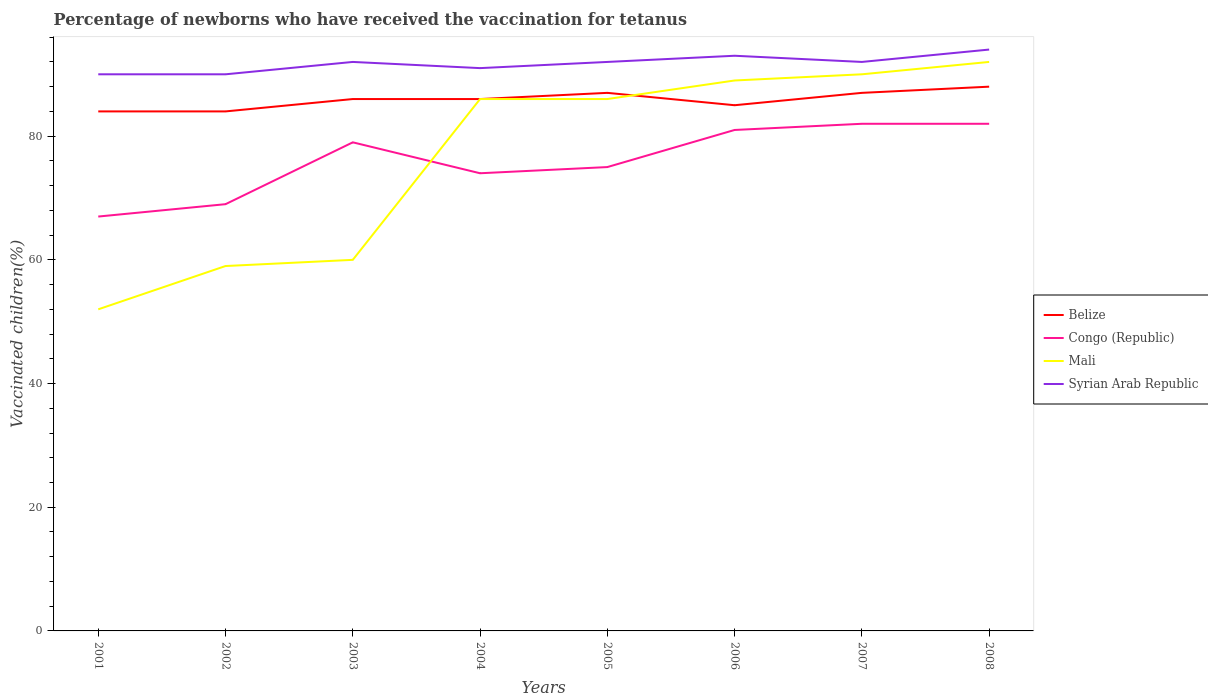How many different coloured lines are there?
Ensure brevity in your answer.  4. Is the number of lines equal to the number of legend labels?
Offer a terse response. Yes. Across all years, what is the maximum percentage of vaccinated children in Mali?
Offer a very short reply. 52. What is the total percentage of vaccinated children in Mali in the graph?
Give a very brief answer. -34. What is the difference between the highest and the second highest percentage of vaccinated children in Syrian Arab Republic?
Your response must be concise. 4. Is the percentage of vaccinated children in Congo (Republic) strictly greater than the percentage of vaccinated children in Belize over the years?
Provide a short and direct response. Yes. How many lines are there?
Keep it short and to the point. 4. Are the values on the major ticks of Y-axis written in scientific E-notation?
Your answer should be compact. No. Does the graph contain grids?
Ensure brevity in your answer.  No. Where does the legend appear in the graph?
Ensure brevity in your answer.  Center right. What is the title of the graph?
Provide a succinct answer. Percentage of newborns who have received the vaccination for tetanus. Does "Central African Republic" appear as one of the legend labels in the graph?
Provide a short and direct response. No. What is the label or title of the X-axis?
Offer a terse response. Years. What is the label or title of the Y-axis?
Offer a very short reply. Vaccinated children(%). What is the Vaccinated children(%) of Syrian Arab Republic in 2001?
Your response must be concise. 90. What is the Vaccinated children(%) in Belize in 2002?
Offer a terse response. 84. What is the Vaccinated children(%) in Congo (Republic) in 2002?
Keep it short and to the point. 69. What is the Vaccinated children(%) in Belize in 2003?
Your answer should be very brief. 86. What is the Vaccinated children(%) in Congo (Republic) in 2003?
Your response must be concise. 79. What is the Vaccinated children(%) in Syrian Arab Republic in 2003?
Give a very brief answer. 92. What is the Vaccinated children(%) of Mali in 2004?
Provide a short and direct response. 86. What is the Vaccinated children(%) in Syrian Arab Republic in 2004?
Provide a short and direct response. 91. What is the Vaccinated children(%) of Congo (Republic) in 2005?
Give a very brief answer. 75. What is the Vaccinated children(%) in Mali in 2005?
Offer a terse response. 86. What is the Vaccinated children(%) of Syrian Arab Republic in 2005?
Offer a very short reply. 92. What is the Vaccinated children(%) in Belize in 2006?
Make the answer very short. 85. What is the Vaccinated children(%) of Mali in 2006?
Offer a terse response. 89. What is the Vaccinated children(%) of Syrian Arab Republic in 2006?
Make the answer very short. 93. What is the Vaccinated children(%) of Belize in 2007?
Your answer should be compact. 87. What is the Vaccinated children(%) in Congo (Republic) in 2007?
Ensure brevity in your answer.  82. What is the Vaccinated children(%) in Syrian Arab Republic in 2007?
Provide a short and direct response. 92. What is the Vaccinated children(%) of Belize in 2008?
Provide a succinct answer. 88. What is the Vaccinated children(%) of Mali in 2008?
Your answer should be very brief. 92. What is the Vaccinated children(%) of Syrian Arab Republic in 2008?
Ensure brevity in your answer.  94. Across all years, what is the maximum Vaccinated children(%) in Belize?
Your response must be concise. 88. Across all years, what is the maximum Vaccinated children(%) of Mali?
Provide a succinct answer. 92. Across all years, what is the maximum Vaccinated children(%) of Syrian Arab Republic?
Ensure brevity in your answer.  94. Across all years, what is the minimum Vaccinated children(%) in Congo (Republic)?
Keep it short and to the point. 67. Across all years, what is the minimum Vaccinated children(%) in Mali?
Keep it short and to the point. 52. Across all years, what is the minimum Vaccinated children(%) of Syrian Arab Republic?
Provide a succinct answer. 90. What is the total Vaccinated children(%) of Belize in the graph?
Provide a short and direct response. 687. What is the total Vaccinated children(%) of Congo (Republic) in the graph?
Ensure brevity in your answer.  609. What is the total Vaccinated children(%) of Mali in the graph?
Make the answer very short. 614. What is the total Vaccinated children(%) of Syrian Arab Republic in the graph?
Give a very brief answer. 734. What is the difference between the Vaccinated children(%) of Congo (Republic) in 2001 and that in 2002?
Keep it short and to the point. -2. What is the difference between the Vaccinated children(%) in Mali in 2001 and that in 2002?
Make the answer very short. -7. What is the difference between the Vaccinated children(%) of Belize in 2001 and that in 2003?
Your answer should be very brief. -2. What is the difference between the Vaccinated children(%) of Congo (Republic) in 2001 and that in 2003?
Offer a terse response. -12. What is the difference between the Vaccinated children(%) of Mali in 2001 and that in 2003?
Provide a short and direct response. -8. What is the difference between the Vaccinated children(%) in Congo (Republic) in 2001 and that in 2004?
Provide a succinct answer. -7. What is the difference between the Vaccinated children(%) of Mali in 2001 and that in 2004?
Your response must be concise. -34. What is the difference between the Vaccinated children(%) in Syrian Arab Republic in 2001 and that in 2004?
Your response must be concise. -1. What is the difference between the Vaccinated children(%) of Congo (Republic) in 2001 and that in 2005?
Provide a succinct answer. -8. What is the difference between the Vaccinated children(%) in Mali in 2001 and that in 2005?
Your answer should be very brief. -34. What is the difference between the Vaccinated children(%) in Syrian Arab Republic in 2001 and that in 2005?
Your response must be concise. -2. What is the difference between the Vaccinated children(%) of Congo (Republic) in 2001 and that in 2006?
Provide a short and direct response. -14. What is the difference between the Vaccinated children(%) in Mali in 2001 and that in 2006?
Make the answer very short. -37. What is the difference between the Vaccinated children(%) of Belize in 2001 and that in 2007?
Ensure brevity in your answer.  -3. What is the difference between the Vaccinated children(%) in Congo (Republic) in 2001 and that in 2007?
Your response must be concise. -15. What is the difference between the Vaccinated children(%) in Mali in 2001 and that in 2007?
Keep it short and to the point. -38. What is the difference between the Vaccinated children(%) in Congo (Republic) in 2001 and that in 2008?
Your answer should be very brief. -15. What is the difference between the Vaccinated children(%) in Syrian Arab Republic in 2001 and that in 2008?
Offer a terse response. -4. What is the difference between the Vaccinated children(%) of Belize in 2002 and that in 2003?
Your answer should be very brief. -2. What is the difference between the Vaccinated children(%) in Belize in 2002 and that in 2004?
Your response must be concise. -2. What is the difference between the Vaccinated children(%) of Congo (Republic) in 2002 and that in 2004?
Keep it short and to the point. -5. What is the difference between the Vaccinated children(%) in Mali in 2002 and that in 2004?
Offer a terse response. -27. What is the difference between the Vaccinated children(%) of Syrian Arab Republic in 2002 and that in 2004?
Your answer should be compact. -1. What is the difference between the Vaccinated children(%) of Congo (Republic) in 2002 and that in 2005?
Offer a terse response. -6. What is the difference between the Vaccinated children(%) in Mali in 2002 and that in 2005?
Keep it short and to the point. -27. What is the difference between the Vaccinated children(%) of Syrian Arab Republic in 2002 and that in 2005?
Your answer should be compact. -2. What is the difference between the Vaccinated children(%) of Belize in 2002 and that in 2007?
Offer a very short reply. -3. What is the difference between the Vaccinated children(%) in Mali in 2002 and that in 2007?
Make the answer very short. -31. What is the difference between the Vaccinated children(%) of Belize in 2002 and that in 2008?
Offer a terse response. -4. What is the difference between the Vaccinated children(%) in Mali in 2002 and that in 2008?
Make the answer very short. -33. What is the difference between the Vaccinated children(%) of Syrian Arab Republic in 2002 and that in 2008?
Make the answer very short. -4. What is the difference between the Vaccinated children(%) in Congo (Republic) in 2003 and that in 2004?
Ensure brevity in your answer.  5. What is the difference between the Vaccinated children(%) of Syrian Arab Republic in 2003 and that in 2004?
Your answer should be compact. 1. What is the difference between the Vaccinated children(%) of Belize in 2003 and that in 2005?
Offer a terse response. -1. What is the difference between the Vaccinated children(%) of Congo (Republic) in 2003 and that in 2005?
Offer a terse response. 4. What is the difference between the Vaccinated children(%) in Mali in 2003 and that in 2005?
Offer a very short reply. -26. What is the difference between the Vaccinated children(%) of Mali in 2003 and that in 2006?
Your response must be concise. -29. What is the difference between the Vaccinated children(%) in Syrian Arab Republic in 2003 and that in 2006?
Your response must be concise. -1. What is the difference between the Vaccinated children(%) in Syrian Arab Republic in 2003 and that in 2007?
Provide a short and direct response. 0. What is the difference between the Vaccinated children(%) in Belize in 2003 and that in 2008?
Provide a succinct answer. -2. What is the difference between the Vaccinated children(%) in Mali in 2003 and that in 2008?
Offer a very short reply. -32. What is the difference between the Vaccinated children(%) in Syrian Arab Republic in 2003 and that in 2008?
Provide a short and direct response. -2. What is the difference between the Vaccinated children(%) in Belize in 2004 and that in 2005?
Provide a short and direct response. -1. What is the difference between the Vaccinated children(%) in Congo (Republic) in 2004 and that in 2005?
Offer a very short reply. -1. What is the difference between the Vaccinated children(%) in Belize in 2004 and that in 2006?
Provide a succinct answer. 1. What is the difference between the Vaccinated children(%) of Congo (Republic) in 2004 and that in 2006?
Offer a very short reply. -7. What is the difference between the Vaccinated children(%) of Mali in 2004 and that in 2006?
Keep it short and to the point. -3. What is the difference between the Vaccinated children(%) of Syrian Arab Republic in 2004 and that in 2006?
Give a very brief answer. -2. What is the difference between the Vaccinated children(%) of Belize in 2004 and that in 2007?
Your answer should be very brief. -1. What is the difference between the Vaccinated children(%) of Congo (Republic) in 2004 and that in 2007?
Your response must be concise. -8. What is the difference between the Vaccinated children(%) of Mali in 2004 and that in 2007?
Ensure brevity in your answer.  -4. What is the difference between the Vaccinated children(%) in Syrian Arab Republic in 2004 and that in 2007?
Provide a short and direct response. -1. What is the difference between the Vaccinated children(%) in Congo (Republic) in 2004 and that in 2008?
Make the answer very short. -8. What is the difference between the Vaccinated children(%) in Belize in 2005 and that in 2008?
Your answer should be very brief. -1. What is the difference between the Vaccinated children(%) of Congo (Republic) in 2005 and that in 2008?
Give a very brief answer. -7. What is the difference between the Vaccinated children(%) of Mali in 2005 and that in 2008?
Your answer should be compact. -6. What is the difference between the Vaccinated children(%) of Syrian Arab Republic in 2005 and that in 2008?
Ensure brevity in your answer.  -2. What is the difference between the Vaccinated children(%) of Belize in 2006 and that in 2007?
Give a very brief answer. -2. What is the difference between the Vaccinated children(%) in Mali in 2006 and that in 2007?
Ensure brevity in your answer.  -1. What is the difference between the Vaccinated children(%) in Mali in 2006 and that in 2008?
Your answer should be compact. -3. What is the difference between the Vaccinated children(%) in Syrian Arab Republic in 2006 and that in 2008?
Your answer should be compact. -1. What is the difference between the Vaccinated children(%) of Syrian Arab Republic in 2007 and that in 2008?
Offer a terse response. -2. What is the difference between the Vaccinated children(%) of Belize in 2001 and the Vaccinated children(%) of Congo (Republic) in 2002?
Ensure brevity in your answer.  15. What is the difference between the Vaccinated children(%) of Congo (Republic) in 2001 and the Vaccinated children(%) of Mali in 2002?
Offer a terse response. 8. What is the difference between the Vaccinated children(%) of Congo (Republic) in 2001 and the Vaccinated children(%) of Syrian Arab Republic in 2002?
Your response must be concise. -23. What is the difference between the Vaccinated children(%) in Mali in 2001 and the Vaccinated children(%) in Syrian Arab Republic in 2002?
Provide a short and direct response. -38. What is the difference between the Vaccinated children(%) of Belize in 2001 and the Vaccinated children(%) of Syrian Arab Republic in 2003?
Offer a very short reply. -8. What is the difference between the Vaccinated children(%) in Congo (Republic) in 2001 and the Vaccinated children(%) in Mali in 2003?
Provide a short and direct response. 7. What is the difference between the Vaccinated children(%) in Congo (Republic) in 2001 and the Vaccinated children(%) in Syrian Arab Republic in 2003?
Provide a succinct answer. -25. What is the difference between the Vaccinated children(%) in Mali in 2001 and the Vaccinated children(%) in Syrian Arab Republic in 2003?
Keep it short and to the point. -40. What is the difference between the Vaccinated children(%) in Belize in 2001 and the Vaccinated children(%) in Congo (Republic) in 2004?
Your answer should be very brief. 10. What is the difference between the Vaccinated children(%) in Belize in 2001 and the Vaccinated children(%) in Mali in 2004?
Your answer should be compact. -2. What is the difference between the Vaccinated children(%) in Congo (Republic) in 2001 and the Vaccinated children(%) in Syrian Arab Republic in 2004?
Provide a succinct answer. -24. What is the difference between the Vaccinated children(%) in Mali in 2001 and the Vaccinated children(%) in Syrian Arab Republic in 2004?
Keep it short and to the point. -39. What is the difference between the Vaccinated children(%) of Belize in 2001 and the Vaccinated children(%) of Syrian Arab Republic in 2005?
Offer a terse response. -8. What is the difference between the Vaccinated children(%) in Congo (Republic) in 2001 and the Vaccinated children(%) in Mali in 2005?
Ensure brevity in your answer.  -19. What is the difference between the Vaccinated children(%) of Belize in 2001 and the Vaccinated children(%) of Congo (Republic) in 2006?
Provide a succinct answer. 3. What is the difference between the Vaccinated children(%) of Belize in 2001 and the Vaccinated children(%) of Syrian Arab Republic in 2006?
Your answer should be very brief. -9. What is the difference between the Vaccinated children(%) of Congo (Republic) in 2001 and the Vaccinated children(%) of Mali in 2006?
Your response must be concise. -22. What is the difference between the Vaccinated children(%) of Congo (Republic) in 2001 and the Vaccinated children(%) of Syrian Arab Republic in 2006?
Provide a short and direct response. -26. What is the difference between the Vaccinated children(%) of Mali in 2001 and the Vaccinated children(%) of Syrian Arab Republic in 2006?
Offer a terse response. -41. What is the difference between the Vaccinated children(%) of Belize in 2001 and the Vaccinated children(%) of Mali in 2007?
Offer a terse response. -6. What is the difference between the Vaccinated children(%) in Mali in 2001 and the Vaccinated children(%) in Syrian Arab Republic in 2007?
Offer a terse response. -40. What is the difference between the Vaccinated children(%) in Belize in 2001 and the Vaccinated children(%) in Congo (Republic) in 2008?
Provide a short and direct response. 2. What is the difference between the Vaccinated children(%) of Belize in 2001 and the Vaccinated children(%) of Syrian Arab Republic in 2008?
Your answer should be compact. -10. What is the difference between the Vaccinated children(%) in Congo (Republic) in 2001 and the Vaccinated children(%) in Mali in 2008?
Offer a very short reply. -25. What is the difference between the Vaccinated children(%) in Mali in 2001 and the Vaccinated children(%) in Syrian Arab Republic in 2008?
Make the answer very short. -42. What is the difference between the Vaccinated children(%) in Belize in 2002 and the Vaccinated children(%) in Congo (Republic) in 2003?
Give a very brief answer. 5. What is the difference between the Vaccinated children(%) of Congo (Republic) in 2002 and the Vaccinated children(%) of Mali in 2003?
Your response must be concise. 9. What is the difference between the Vaccinated children(%) of Mali in 2002 and the Vaccinated children(%) of Syrian Arab Republic in 2003?
Give a very brief answer. -33. What is the difference between the Vaccinated children(%) of Belize in 2002 and the Vaccinated children(%) of Congo (Republic) in 2004?
Provide a succinct answer. 10. What is the difference between the Vaccinated children(%) in Belize in 2002 and the Vaccinated children(%) in Syrian Arab Republic in 2004?
Your answer should be very brief. -7. What is the difference between the Vaccinated children(%) of Congo (Republic) in 2002 and the Vaccinated children(%) of Mali in 2004?
Offer a terse response. -17. What is the difference between the Vaccinated children(%) in Mali in 2002 and the Vaccinated children(%) in Syrian Arab Republic in 2004?
Your response must be concise. -32. What is the difference between the Vaccinated children(%) of Belize in 2002 and the Vaccinated children(%) of Congo (Republic) in 2005?
Offer a very short reply. 9. What is the difference between the Vaccinated children(%) of Belize in 2002 and the Vaccinated children(%) of Mali in 2005?
Offer a terse response. -2. What is the difference between the Vaccinated children(%) of Belize in 2002 and the Vaccinated children(%) of Syrian Arab Republic in 2005?
Your response must be concise. -8. What is the difference between the Vaccinated children(%) of Congo (Republic) in 2002 and the Vaccinated children(%) of Mali in 2005?
Your answer should be very brief. -17. What is the difference between the Vaccinated children(%) in Mali in 2002 and the Vaccinated children(%) in Syrian Arab Republic in 2005?
Provide a short and direct response. -33. What is the difference between the Vaccinated children(%) in Belize in 2002 and the Vaccinated children(%) in Congo (Republic) in 2006?
Your answer should be compact. 3. What is the difference between the Vaccinated children(%) of Mali in 2002 and the Vaccinated children(%) of Syrian Arab Republic in 2006?
Keep it short and to the point. -34. What is the difference between the Vaccinated children(%) of Belize in 2002 and the Vaccinated children(%) of Congo (Republic) in 2007?
Offer a terse response. 2. What is the difference between the Vaccinated children(%) of Belize in 2002 and the Vaccinated children(%) of Mali in 2007?
Ensure brevity in your answer.  -6. What is the difference between the Vaccinated children(%) of Mali in 2002 and the Vaccinated children(%) of Syrian Arab Republic in 2007?
Your response must be concise. -33. What is the difference between the Vaccinated children(%) of Belize in 2002 and the Vaccinated children(%) of Mali in 2008?
Ensure brevity in your answer.  -8. What is the difference between the Vaccinated children(%) in Congo (Republic) in 2002 and the Vaccinated children(%) in Mali in 2008?
Your response must be concise. -23. What is the difference between the Vaccinated children(%) in Mali in 2002 and the Vaccinated children(%) in Syrian Arab Republic in 2008?
Provide a succinct answer. -35. What is the difference between the Vaccinated children(%) of Belize in 2003 and the Vaccinated children(%) of Mali in 2004?
Your answer should be very brief. 0. What is the difference between the Vaccinated children(%) in Belize in 2003 and the Vaccinated children(%) in Syrian Arab Republic in 2004?
Keep it short and to the point. -5. What is the difference between the Vaccinated children(%) in Congo (Republic) in 2003 and the Vaccinated children(%) in Syrian Arab Republic in 2004?
Offer a terse response. -12. What is the difference between the Vaccinated children(%) of Mali in 2003 and the Vaccinated children(%) of Syrian Arab Republic in 2004?
Give a very brief answer. -31. What is the difference between the Vaccinated children(%) of Belize in 2003 and the Vaccinated children(%) of Congo (Republic) in 2005?
Give a very brief answer. 11. What is the difference between the Vaccinated children(%) in Congo (Republic) in 2003 and the Vaccinated children(%) in Syrian Arab Republic in 2005?
Provide a succinct answer. -13. What is the difference between the Vaccinated children(%) of Mali in 2003 and the Vaccinated children(%) of Syrian Arab Republic in 2005?
Keep it short and to the point. -32. What is the difference between the Vaccinated children(%) of Belize in 2003 and the Vaccinated children(%) of Mali in 2006?
Your response must be concise. -3. What is the difference between the Vaccinated children(%) in Congo (Republic) in 2003 and the Vaccinated children(%) in Mali in 2006?
Provide a succinct answer. -10. What is the difference between the Vaccinated children(%) in Mali in 2003 and the Vaccinated children(%) in Syrian Arab Republic in 2006?
Offer a terse response. -33. What is the difference between the Vaccinated children(%) in Belize in 2003 and the Vaccinated children(%) in Mali in 2007?
Provide a short and direct response. -4. What is the difference between the Vaccinated children(%) of Belize in 2003 and the Vaccinated children(%) of Syrian Arab Republic in 2007?
Your response must be concise. -6. What is the difference between the Vaccinated children(%) of Congo (Republic) in 2003 and the Vaccinated children(%) of Mali in 2007?
Ensure brevity in your answer.  -11. What is the difference between the Vaccinated children(%) in Mali in 2003 and the Vaccinated children(%) in Syrian Arab Republic in 2007?
Provide a succinct answer. -32. What is the difference between the Vaccinated children(%) of Belize in 2003 and the Vaccinated children(%) of Congo (Republic) in 2008?
Offer a very short reply. 4. What is the difference between the Vaccinated children(%) in Belize in 2003 and the Vaccinated children(%) in Syrian Arab Republic in 2008?
Give a very brief answer. -8. What is the difference between the Vaccinated children(%) of Congo (Republic) in 2003 and the Vaccinated children(%) of Mali in 2008?
Your response must be concise. -13. What is the difference between the Vaccinated children(%) in Mali in 2003 and the Vaccinated children(%) in Syrian Arab Republic in 2008?
Your answer should be compact. -34. What is the difference between the Vaccinated children(%) of Belize in 2004 and the Vaccinated children(%) of Syrian Arab Republic in 2005?
Offer a very short reply. -6. What is the difference between the Vaccinated children(%) of Congo (Republic) in 2004 and the Vaccinated children(%) of Mali in 2005?
Your answer should be compact. -12. What is the difference between the Vaccinated children(%) of Mali in 2004 and the Vaccinated children(%) of Syrian Arab Republic in 2005?
Offer a very short reply. -6. What is the difference between the Vaccinated children(%) of Belize in 2004 and the Vaccinated children(%) of Congo (Republic) in 2006?
Your answer should be very brief. 5. What is the difference between the Vaccinated children(%) in Belize in 2004 and the Vaccinated children(%) in Mali in 2006?
Give a very brief answer. -3. What is the difference between the Vaccinated children(%) in Congo (Republic) in 2004 and the Vaccinated children(%) in Mali in 2006?
Keep it short and to the point. -15. What is the difference between the Vaccinated children(%) in Congo (Republic) in 2004 and the Vaccinated children(%) in Syrian Arab Republic in 2006?
Offer a terse response. -19. What is the difference between the Vaccinated children(%) in Belize in 2004 and the Vaccinated children(%) in Mali in 2007?
Your answer should be compact. -4. What is the difference between the Vaccinated children(%) in Belize in 2004 and the Vaccinated children(%) in Congo (Republic) in 2008?
Give a very brief answer. 4. What is the difference between the Vaccinated children(%) in Congo (Republic) in 2004 and the Vaccinated children(%) in Mali in 2008?
Make the answer very short. -18. What is the difference between the Vaccinated children(%) in Congo (Republic) in 2004 and the Vaccinated children(%) in Syrian Arab Republic in 2008?
Offer a very short reply. -20. What is the difference between the Vaccinated children(%) in Mali in 2004 and the Vaccinated children(%) in Syrian Arab Republic in 2008?
Offer a very short reply. -8. What is the difference between the Vaccinated children(%) in Belize in 2005 and the Vaccinated children(%) in Congo (Republic) in 2006?
Ensure brevity in your answer.  6. What is the difference between the Vaccinated children(%) in Belize in 2005 and the Vaccinated children(%) in Syrian Arab Republic in 2006?
Your answer should be compact. -6. What is the difference between the Vaccinated children(%) in Congo (Republic) in 2005 and the Vaccinated children(%) in Syrian Arab Republic in 2006?
Offer a very short reply. -18. What is the difference between the Vaccinated children(%) in Belize in 2005 and the Vaccinated children(%) in Congo (Republic) in 2007?
Give a very brief answer. 5. What is the difference between the Vaccinated children(%) in Belize in 2005 and the Vaccinated children(%) in Mali in 2007?
Offer a terse response. -3. What is the difference between the Vaccinated children(%) in Belize in 2005 and the Vaccinated children(%) in Syrian Arab Republic in 2007?
Make the answer very short. -5. What is the difference between the Vaccinated children(%) of Mali in 2005 and the Vaccinated children(%) of Syrian Arab Republic in 2007?
Make the answer very short. -6. What is the difference between the Vaccinated children(%) in Belize in 2005 and the Vaccinated children(%) in Syrian Arab Republic in 2008?
Give a very brief answer. -7. What is the difference between the Vaccinated children(%) in Congo (Republic) in 2005 and the Vaccinated children(%) in Mali in 2008?
Offer a terse response. -17. What is the difference between the Vaccinated children(%) of Belize in 2006 and the Vaccinated children(%) of Mali in 2007?
Give a very brief answer. -5. What is the difference between the Vaccinated children(%) in Belize in 2006 and the Vaccinated children(%) in Syrian Arab Republic in 2007?
Your response must be concise. -7. What is the difference between the Vaccinated children(%) of Congo (Republic) in 2006 and the Vaccinated children(%) of Syrian Arab Republic in 2007?
Give a very brief answer. -11. What is the difference between the Vaccinated children(%) in Mali in 2006 and the Vaccinated children(%) in Syrian Arab Republic in 2007?
Offer a terse response. -3. What is the difference between the Vaccinated children(%) of Belize in 2006 and the Vaccinated children(%) of Congo (Republic) in 2008?
Offer a terse response. 3. What is the difference between the Vaccinated children(%) of Belize in 2006 and the Vaccinated children(%) of Syrian Arab Republic in 2008?
Ensure brevity in your answer.  -9. What is the difference between the Vaccinated children(%) of Mali in 2006 and the Vaccinated children(%) of Syrian Arab Republic in 2008?
Offer a very short reply. -5. What is the difference between the Vaccinated children(%) of Belize in 2007 and the Vaccinated children(%) of Congo (Republic) in 2008?
Provide a succinct answer. 5. What is the difference between the Vaccinated children(%) of Belize in 2007 and the Vaccinated children(%) of Mali in 2008?
Provide a succinct answer. -5. What is the difference between the Vaccinated children(%) in Belize in 2007 and the Vaccinated children(%) in Syrian Arab Republic in 2008?
Make the answer very short. -7. What is the difference between the Vaccinated children(%) in Mali in 2007 and the Vaccinated children(%) in Syrian Arab Republic in 2008?
Offer a very short reply. -4. What is the average Vaccinated children(%) of Belize per year?
Your response must be concise. 85.88. What is the average Vaccinated children(%) in Congo (Republic) per year?
Offer a very short reply. 76.12. What is the average Vaccinated children(%) of Mali per year?
Your answer should be very brief. 76.75. What is the average Vaccinated children(%) of Syrian Arab Republic per year?
Offer a terse response. 91.75. In the year 2001, what is the difference between the Vaccinated children(%) in Belize and Vaccinated children(%) in Congo (Republic)?
Your answer should be compact. 17. In the year 2001, what is the difference between the Vaccinated children(%) in Belize and Vaccinated children(%) in Syrian Arab Republic?
Provide a succinct answer. -6. In the year 2001, what is the difference between the Vaccinated children(%) of Mali and Vaccinated children(%) of Syrian Arab Republic?
Make the answer very short. -38. In the year 2002, what is the difference between the Vaccinated children(%) of Belize and Vaccinated children(%) of Congo (Republic)?
Ensure brevity in your answer.  15. In the year 2002, what is the difference between the Vaccinated children(%) of Belize and Vaccinated children(%) of Mali?
Give a very brief answer. 25. In the year 2002, what is the difference between the Vaccinated children(%) in Congo (Republic) and Vaccinated children(%) in Mali?
Offer a terse response. 10. In the year 2002, what is the difference between the Vaccinated children(%) in Congo (Republic) and Vaccinated children(%) in Syrian Arab Republic?
Your answer should be very brief. -21. In the year 2002, what is the difference between the Vaccinated children(%) of Mali and Vaccinated children(%) of Syrian Arab Republic?
Your answer should be compact. -31. In the year 2003, what is the difference between the Vaccinated children(%) of Belize and Vaccinated children(%) of Mali?
Your answer should be very brief. 26. In the year 2003, what is the difference between the Vaccinated children(%) in Belize and Vaccinated children(%) in Syrian Arab Republic?
Offer a terse response. -6. In the year 2003, what is the difference between the Vaccinated children(%) of Congo (Republic) and Vaccinated children(%) of Mali?
Give a very brief answer. 19. In the year 2003, what is the difference between the Vaccinated children(%) in Mali and Vaccinated children(%) in Syrian Arab Republic?
Make the answer very short. -32. In the year 2004, what is the difference between the Vaccinated children(%) of Belize and Vaccinated children(%) of Mali?
Offer a terse response. 0. In the year 2004, what is the difference between the Vaccinated children(%) in Belize and Vaccinated children(%) in Syrian Arab Republic?
Keep it short and to the point. -5. In the year 2004, what is the difference between the Vaccinated children(%) of Congo (Republic) and Vaccinated children(%) of Mali?
Ensure brevity in your answer.  -12. In the year 2004, what is the difference between the Vaccinated children(%) of Congo (Republic) and Vaccinated children(%) of Syrian Arab Republic?
Your answer should be very brief. -17. In the year 2005, what is the difference between the Vaccinated children(%) in Belize and Vaccinated children(%) in Syrian Arab Republic?
Your answer should be very brief. -5. In the year 2005, what is the difference between the Vaccinated children(%) of Congo (Republic) and Vaccinated children(%) of Syrian Arab Republic?
Keep it short and to the point. -17. In the year 2005, what is the difference between the Vaccinated children(%) in Mali and Vaccinated children(%) in Syrian Arab Republic?
Provide a short and direct response. -6. In the year 2006, what is the difference between the Vaccinated children(%) in Belize and Vaccinated children(%) in Syrian Arab Republic?
Your response must be concise. -8. In the year 2006, what is the difference between the Vaccinated children(%) of Congo (Republic) and Vaccinated children(%) of Mali?
Your answer should be very brief. -8. In the year 2006, what is the difference between the Vaccinated children(%) of Congo (Republic) and Vaccinated children(%) of Syrian Arab Republic?
Make the answer very short. -12. In the year 2006, what is the difference between the Vaccinated children(%) in Mali and Vaccinated children(%) in Syrian Arab Republic?
Your answer should be compact. -4. In the year 2007, what is the difference between the Vaccinated children(%) of Belize and Vaccinated children(%) of Congo (Republic)?
Offer a very short reply. 5. In the year 2007, what is the difference between the Vaccinated children(%) of Belize and Vaccinated children(%) of Mali?
Give a very brief answer. -3. In the year 2007, what is the difference between the Vaccinated children(%) of Congo (Republic) and Vaccinated children(%) of Mali?
Offer a terse response. -8. In the year 2007, what is the difference between the Vaccinated children(%) of Congo (Republic) and Vaccinated children(%) of Syrian Arab Republic?
Give a very brief answer. -10. In the year 2007, what is the difference between the Vaccinated children(%) of Mali and Vaccinated children(%) of Syrian Arab Republic?
Provide a short and direct response. -2. In the year 2008, what is the difference between the Vaccinated children(%) in Belize and Vaccinated children(%) in Congo (Republic)?
Offer a very short reply. 6. In the year 2008, what is the difference between the Vaccinated children(%) in Belize and Vaccinated children(%) in Mali?
Your answer should be very brief. -4. In the year 2008, what is the difference between the Vaccinated children(%) of Congo (Republic) and Vaccinated children(%) of Mali?
Your answer should be compact. -10. In the year 2008, what is the difference between the Vaccinated children(%) in Mali and Vaccinated children(%) in Syrian Arab Republic?
Provide a short and direct response. -2. What is the ratio of the Vaccinated children(%) of Belize in 2001 to that in 2002?
Provide a succinct answer. 1. What is the ratio of the Vaccinated children(%) in Mali in 2001 to that in 2002?
Keep it short and to the point. 0.88. What is the ratio of the Vaccinated children(%) in Belize in 2001 to that in 2003?
Your answer should be very brief. 0.98. What is the ratio of the Vaccinated children(%) in Congo (Republic) in 2001 to that in 2003?
Offer a very short reply. 0.85. What is the ratio of the Vaccinated children(%) in Mali in 2001 to that in 2003?
Keep it short and to the point. 0.87. What is the ratio of the Vaccinated children(%) in Syrian Arab Republic in 2001 to that in 2003?
Ensure brevity in your answer.  0.98. What is the ratio of the Vaccinated children(%) of Belize in 2001 to that in 2004?
Make the answer very short. 0.98. What is the ratio of the Vaccinated children(%) of Congo (Republic) in 2001 to that in 2004?
Your answer should be very brief. 0.91. What is the ratio of the Vaccinated children(%) in Mali in 2001 to that in 2004?
Offer a very short reply. 0.6. What is the ratio of the Vaccinated children(%) of Syrian Arab Republic in 2001 to that in 2004?
Your response must be concise. 0.99. What is the ratio of the Vaccinated children(%) of Belize in 2001 to that in 2005?
Offer a terse response. 0.97. What is the ratio of the Vaccinated children(%) of Congo (Republic) in 2001 to that in 2005?
Keep it short and to the point. 0.89. What is the ratio of the Vaccinated children(%) of Mali in 2001 to that in 2005?
Keep it short and to the point. 0.6. What is the ratio of the Vaccinated children(%) in Syrian Arab Republic in 2001 to that in 2005?
Offer a very short reply. 0.98. What is the ratio of the Vaccinated children(%) in Belize in 2001 to that in 2006?
Your answer should be very brief. 0.99. What is the ratio of the Vaccinated children(%) in Congo (Republic) in 2001 to that in 2006?
Provide a short and direct response. 0.83. What is the ratio of the Vaccinated children(%) in Mali in 2001 to that in 2006?
Give a very brief answer. 0.58. What is the ratio of the Vaccinated children(%) in Belize in 2001 to that in 2007?
Provide a succinct answer. 0.97. What is the ratio of the Vaccinated children(%) in Congo (Republic) in 2001 to that in 2007?
Give a very brief answer. 0.82. What is the ratio of the Vaccinated children(%) of Mali in 2001 to that in 2007?
Provide a short and direct response. 0.58. What is the ratio of the Vaccinated children(%) in Syrian Arab Republic in 2001 to that in 2007?
Ensure brevity in your answer.  0.98. What is the ratio of the Vaccinated children(%) of Belize in 2001 to that in 2008?
Provide a succinct answer. 0.95. What is the ratio of the Vaccinated children(%) of Congo (Republic) in 2001 to that in 2008?
Ensure brevity in your answer.  0.82. What is the ratio of the Vaccinated children(%) of Mali in 2001 to that in 2008?
Provide a succinct answer. 0.57. What is the ratio of the Vaccinated children(%) of Syrian Arab Republic in 2001 to that in 2008?
Keep it short and to the point. 0.96. What is the ratio of the Vaccinated children(%) of Belize in 2002 to that in 2003?
Keep it short and to the point. 0.98. What is the ratio of the Vaccinated children(%) in Congo (Republic) in 2002 to that in 2003?
Your answer should be compact. 0.87. What is the ratio of the Vaccinated children(%) in Mali in 2002 to that in 2003?
Offer a terse response. 0.98. What is the ratio of the Vaccinated children(%) of Syrian Arab Republic in 2002 to that in 2003?
Offer a terse response. 0.98. What is the ratio of the Vaccinated children(%) in Belize in 2002 to that in 2004?
Your answer should be very brief. 0.98. What is the ratio of the Vaccinated children(%) of Congo (Republic) in 2002 to that in 2004?
Your answer should be very brief. 0.93. What is the ratio of the Vaccinated children(%) of Mali in 2002 to that in 2004?
Your answer should be very brief. 0.69. What is the ratio of the Vaccinated children(%) of Belize in 2002 to that in 2005?
Your response must be concise. 0.97. What is the ratio of the Vaccinated children(%) of Mali in 2002 to that in 2005?
Ensure brevity in your answer.  0.69. What is the ratio of the Vaccinated children(%) of Syrian Arab Republic in 2002 to that in 2005?
Your answer should be compact. 0.98. What is the ratio of the Vaccinated children(%) in Congo (Republic) in 2002 to that in 2006?
Your response must be concise. 0.85. What is the ratio of the Vaccinated children(%) of Mali in 2002 to that in 2006?
Give a very brief answer. 0.66. What is the ratio of the Vaccinated children(%) in Belize in 2002 to that in 2007?
Give a very brief answer. 0.97. What is the ratio of the Vaccinated children(%) in Congo (Republic) in 2002 to that in 2007?
Offer a very short reply. 0.84. What is the ratio of the Vaccinated children(%) of Mali in 2002 to that in 2007?
Ensure brevity in your answer.  0.66. What is the ratio of the Vaccinated children(%) in Syrian Arab Republic in 2002 to that in 2007?
Provide a short and direct response. 0.98. What is the ratio of the Vaccinated children(%) of Belize in 2002 to that in 2008?
Offer a terse response. 0.95. What is the ratio of the Vaccinated children(%) of Congo (Republic) in 2002 to that in 2008?
Give a very brief answer. 0.84. What is the ratio of the Vaccinated children(%) in Mali in 2002 to that in 2008?
Give a very brief answer. 0.64. What is the ratio of the Vaccinated children(%) of Syrian Arab Republic in 2002 to that in 2008?
Ensure brevity in your answer.  0.96. What is the ratio of the Vaccinated children(%) of Congo (Republic) in 2003 to that in 2004?
Give a very brief answer. 1.07. What is the ratio of the Vaccinated children(%) of Mali in 2003 to that in 2004?
Make the answer very short. 0.7. What is the ratio of the Vaccinated children(%) in Belize in 2003 to that in 2005?
Offer a very short reply. 0.99. What is the ratio of the Vaccinated children(%) in Congo (Republic) in 2003 to that in 2005?
Give a very brief answer. 1.05. What is the ratio of the Vaccinated children(%) of Mali in 2003 to that in 2005?
Your answer should be compact. 0.7. What is the ratio of the Vaccinated children(%) in Syrian Arab Republic in 2003 to that in 2005?
Provide a short and direct response. 1. What is the ratio of the Vaccinated children(%) of Belize in 2003 to that in 2006?
Your response must be concise. 1.01. What is the ratio of the Vaccinated children(%) in Congo (Republic) in 2003 to that in 2006?
Offer a very short reply. 0.98. What is the ratio of the Vaccinated children(%) of Mali in 2003 to that in 2006?
Make the answer very short. 0.67. What is the ratio of the Vaccinated children(%) of Congo (Republic) in 2003 to that in 2007?
Offer a very short reply. 0.96. What is the ratio of the Vaccinated children(%) of Syrian Arab Republic in 2003 to that in 2007?
Make the answer very short. 1. What is the ratio of the Vaccinated children(%) in Belize in 2003 to that in 2008?
Your answer should be very brief. 0.98. What is the ratio of the Vaccinated children(%) of Congo (Republic) in 2003 to that in 2008?
Provide a short and direct response. 0.96. What is the ratio of the Vaccinated children(%) of Mali in 2003 to that in 2008?
Your answer should be compact. 0.65. What is the ratio of the Vaccinated children(%) of Syrian Arab Republic in 2003 to that in 2008?
Ensure brevity in your answer.  0.98. What is the ratio of the Vaccinated children(%) in Congo (Republic) in 2004 to that in 2005?
Make the answer very short. 0.99. What is the ratio of the Vaccinated children(%) of Syrian Arab Republic in 2004 to that in 2005?
Provide a short and direct response. 0.99. What is the ratio of the Vaccinated children(%) of Belize in 2004 to that in 2006?
Ensure brevity in your answer.  1.01. What is the ratio of the Vaccinated children(%) of Congo (Republic) in 2004 to that in 2006?
Your answer should be very brief. 0.91. What is the ratio of the Vaccinated children(%) of Mali in 2004 to that in 2006?
Your response must be concise. 0.97. What is the ratio of the Vaccinated children(%) of Syrian Arab Republic in 2004 to that in 2006?
Offer a terse response. 0.98. What is the ratio of the Vaccinated children(%) in Belize in 2004 to that in 2007?
Your answer should be very brief. 0.99. What is the ratio of the Vaccinated children(%) in Congo (Republic) in 2004 to that in 2007?
Keep it short and to the point. 0.9. What is the ratio of the Vaccinated children(%) of Mali in 2004 to that in 2007?
Your answer should be very brief. 0.96. What is the ratio of the Vaccinated children(%) of Syrian Arab Republic in 2004 to that in 2007?
Keep it short and to the point. 0.99. What is the ratio of the Vaccinated children(%) in Belize in 2004 to that in 2008?
Provide a succinct answer. 0.98. What is the ratio of the Vaccinated children(%) of Congo (Republic) in 2004 to that in 2008?
Ensure brevity in your answer.  0.9. What is the ratio of the Vaccinated children(%) of Mali in 2004 to that in 2008?
Make the answer very short. 0.93. What is the ratio of the Vaccinated children(%) in Syrian Arab Republic in 2004 to that in 2008?
Provide a short and direct response. 0.97. What is the ratio of the Vaccinated children(%) of Belize in 2005 to that in 2006?
Ensure brevity in your answer.  1.02. What is the ratio of the Vaccinated children(%) in Congo (Republic) in 2005 to that in 2006?
Make the answer very short. 0.93. What is the ratio of the Vaccinated children(%) of Mali in 2005 to that in 2006?
Your answer should be compact. 0.97. What is the ratio of the Vaccinated children(%) of Congo (Republic) in 2005 to that in 2007?
Your response must be concise. 0.91. What is the ratio of the Vaccinated children(%) of Mali in 2005 to that in 2007?
Provide a succinct answer. 0.96. What is the ratio of the Vaccinated children(%) of Syrian Arab Republic in 2005 to that in 2007?
Make the answer very short. 1. What is the ratio of the Vaccinated children(%) in Belize in 2005 to that in 2008?
Give a very brief answer. 0.99. What is the ratio of the Vaccinated children(%) in Congo (Republic) in 2005 to that in 2008?
Make the answer very short. 0.91. What is the ratio of the Vaccinated children(%) in Mali in 2005 to that in 2008?
Give a very brief answer. 0.93. What is the ratio of the Vaccinated children(%) in Syrian Arab Republic in 2005 to that in 2008?
Your answer should be compact. 0.98. What is the ratio of the Vaccinated children(%) in Congo (Republic) in 2006 to that in 2007?
Keep it short and to the point. 0.99. What is the ratio of the Vaccinated children(%) in Mali in 2006 to that in 2007?
Make the answer very short. 0.99. What is the ratio of the Vaccinated children(%) in Syrian Arab Republic in 2006 to that in 2007?
Offer a very short reply. 1.01. What is the ratio of the Vaccinated children(%) in Belize in 2006 to that in 2008?
Keep it short and to the point. 0.97. What is the ratio of the Vaccinated children(%) of Mali in 2006 to that in 2008?
Make the answer very short. 0.97. What is the ratio of the Vaccinated children(%) in Syrian Arab Republic in 2006 to that in 2008?
Ensure brevity in your answer.  0.99. What is the ratio of the Vaccinated children(%) in Belize in 2007 to that in 2008?
Your answer should be very brief. 0.99. What is the ratio of the Vaccinated children(%) in Congo (Republic) in 2007 to that in 2008?
Ensure brevity in your answer.  1. What is the ratio of the Vaccinated children(%) of Mali in 2007 to that in 2008?
Offer a very short reply. 0.98. What is the ratio of the Vaccinated children(%) in Syrian Arab Republic in 2007 to that in 2008?
Your answer should be compact. 0.98. What is the difference between the highest and the second highest Vaccinated children(%) in Belize?
Give a very brief answer. 1. What is the difference between the highest and the second highest Vaccinated children(%) in Congo (Republic)?
Keep it short and to the point. 0. What is the difference between the highest and the lowest Vaccinated children(%) in Belize?
Make the answer very short. 4. What is the difference between the highest and the lowest Vaccinated children(%) of Syrian Arab Republic?
Offer a very short reply. 4. 